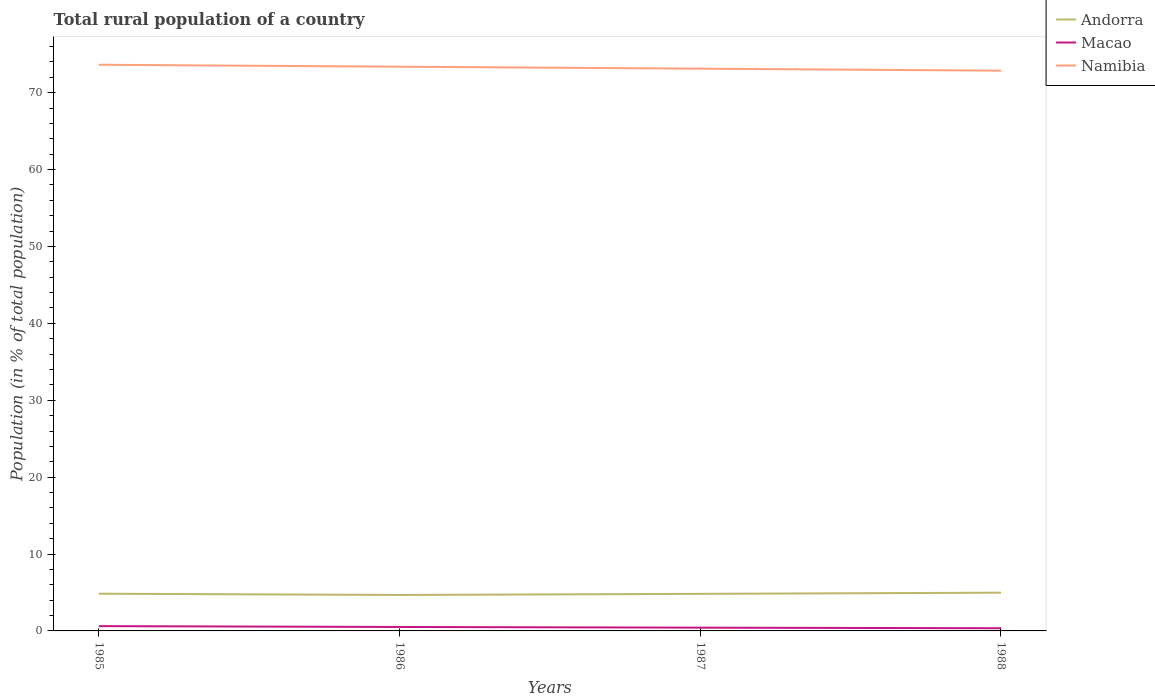Does the line corresponding to Andorra intersect with the line corresponding to Namibia?
Your response must be concise. No. Is the number of lines equal to the number of legend labels?
Your response must be concise. Yes. Across all years, what is the maximum rural population in Andorra?
Make the answer very short. 4.67. What is the total rural population in Macao in the graph?
Keep it short and to the point. 0.27. What is the difference between the highest and the second highest rural population in Macao?
Ensure brevity in your answer.  0.27. What is the difference between the highest and the lowest rural population in Macao?
Ensure brevity in your answer.  2. Is the rural population in Namibia strictly greater than the rural population in Macao over the years?
Offer a terse response. No. Does the graph contain any zero values?
Give a very brief answer. No. How many legend labels are there?
Keep it short and to the point. 3. What is the title of the graph?
Provide a short and direct response. Total rural population of a country. Does "Andorra" appear as one of the legend labels in the graph?
Offer a terse response. Yes. What is the label or title of the Y-axis?
Provide a succinct answer. Population (in % of total population). What is the Population (in % of total population) of Andorra in 1985?
Offer a very short reply. 4.84. What is the Population (in % of total population) of Macao in 1985?
Provide a short and direct response. 0.62. What is the Population (in % of total population) of Namibia in 1985?
Your response must be concise. 73.63. What is the Population (in % of total population) in Andorra in 1986?
Provide a succinct answer. 4.67. What is the Population (in % of total population) in Macao in 1986?
Your answer should be compact. 0.51. What is the Population (in % of total population) in Namibia in 1986?
Your answer should be compact. 73.38. What is the Population (in % of total population) of Andorra in 1987?
Give a very brief answer. 4.82. What is the Population (in % of total population) of Macao in 1987?
Your answer should be very brief. 0.42. What is the Population (in % of total population) of Namibia in 1987?
Your answer should be very brief. 73.12. What is the Population (in % of total population) of Andorra in 1988?
Your answer should be compact. 4.97. What is the Population (in % of total population) of Macao in 1988?
Keep it short and to the point. 0.35. What is the Population (in % of total population) in Namibia in 1988?
Keep it short and to the point. 72.86. Across all years, what is the maximum Population (in % of total population) in Andorra?
Provide a short and direct response. 4.97. Across all years, what is the maximum Population (in % of total population) in Macao?
Provide a succinct answer. 0.62. Across all years, what is the maximum Population (in % of total population) in Namibia?
Offer a very short reply. 73.63. Across all years, what is the minimum Population (in % of total population) in Andorra?
Your answer should be compact. 4.67. Across all years, what is the minimum Population (in % of total population) of Macao?
Make the answer very short. 0.35. Across all years, what is the minimum Population (in % of total population) in Namibia?
Offer a very short reply. 72.86. What is the total Population (in % of total population) of Andorra in the graph?
Your response must be concise. 19.31. What is the total Population (in % of total population) of Macao in the graph?
Provide a succinct answer. 1.91. What is the total Population (in % of total population) in Namibia in the graph?
Offer a very short reply. 293. What is the difference between the Population (in % of total population) in Andorra in 1985 and that in 1986?
Offer a terse response. 0.17. What is the difference between the Population (in % of total population) in Macao in 1985 and that in 1986?
Offer a terse response. 0.11. What is the difference between the Population (in % of total population) in Namibia in 1985 and that in 1986?
Your answer should be very brief. 0.26. What is the difference between the Population (in % of total population) in Andorra in 1985 and that in 1987?
Make the answer very short. 0.02. What is the difference between the Population (in % of total population) of Macao in 1985 and that in 1987?
Provide a short and direct response. 0.2. What is the difference between the Population (in % of total population) in Namibia in 1985 and that in 1987?
Offer a very short reply. 0.51. What is the difference between the Population (in % of total population) of Andorra in 1985 and that in 1988?
Offer a terse response. -0.13. What is the difference between the Population (in % of total population) of Macao in 1985 and that in 1988?
Your answer should be compact. 0.27. What is the difference between the Population (in % of total population) in Namibia in 1985 and that in 1988?
Offer a terse response. 0.77. What is the difference between the Population (in % of total population) in Andorra in 1986 and that in 1987?
Give a very brief answer. -0.15. What is the difference between the Population (in % of total population) in Macao in 1986 and that in 1987?
Provide a short and direct response. 0.09. What is the difference between the Population (in % of total population) of Namibia in 1986 and that in 1987?
Offer a very short reply. 0.26. What is the difference between the Population (in % of total population) of Andorra in 1986 and that in 1988?
Make the answer very short. -0.3. What is the difference between the Population (in % of total population) of Macao in 1986 and that in 1988?
Provide a succinct answer. 0.17. What is the difference between the Population (in % of total population) of Namibia in 1986 and that in 1988?
Make the answer very short. 0.52. What is the difference between the Population (in % of total population) of Andorra in 1987 and that in 1988?
Ensure brevity in your answer.  -0.15. What is the difference between the Population (in % of total population) of Macao in 1987 and that in 1988?
Ensure brevity in your answer.  0.07. What is the difference between the Population (in % of total population) of Namibia in 1987 and that in 1988?
Offer a very short reply. 0.26. What is the difference between the Population (in % of total population) of Andorra in 1985 and the Population (in % of total population) of Macao in 1986?
Keep it short and to the point. 4.33. What is the difference between the Population (in % of total population) of Andorra in 1985 and the Population (in % of total population) of Namibia in 1986?
Offer a very short reply. -68.54. What is the difference between the Population (in % of total population) in Macao in 1985 and the Population (in % of total population) in Namibia in 1986?
Your response must be concise. -72.76. What is the difference between the Population (in % of total population) in Andorra in 1985 and the Population (in % of total population) in Macao in 1987?
Keep it short and to the point. 4.42. What is the difference between the Population (in % of total population) in Andorra in 1985 and the Population (in % of total population) in Namibia in 1987?
Provide a short and direct response. -68.28. What is the difference between the Population (in % of total population) of Macao in 1985 and the Population (in % of total population) of Namibia in 1987?
Provide a succinct answer. -72.5. What is the difference between the Population (in % of total population) of Andorra in 1985 and the Population (in % of total population) of Macao in 1988?
Ensure brevity in your answer.  4.49. What is the difference between the Population (in % of total population) of Andorra in 1985 and the Population (in % of total population) of Namibia in 1988?
Make the answer very short. -68.02. What is the difference between the Population (in % of total population) in Macao in 1985 and the Population (in % of total population) in Namibia in 1988?
Give a very brief answer. -72.24. What is the difference between the Population (in % of total population) of Andorra in 1986 and the Population (in % of total population) of Macao in 1987?
Provide a succinct answer. 4.25. What is the difference between the Population (in % of total population) of Andorra in 1986 and the Population (in % of total population) of Namibia in 1987?
Give a very brief answer. -68.45. What is the difference between the Population (in % of total population) of Macao in 1986 and the Population (in % of total population) of Namibia in 1987?
Offer a terse response. -72.61. What is the difference between the Population (in % of total population) of Andorra in 1986 and the Population (in % of total population) of Macao in 1988?
Offer a terse response. 4.33. What is the difference between the Population (in % of total population) of Andorra in 1986 and the Population (in % of total population) of Namibia in 1988?
Your response must be concise. -68.19. What is the difference between the Population (in % of total population) of Macao in 1986 and the Population (in % of total population) of Namibia in 1988?
Provide a short and direct response. -72.35. What is the difference between the Population (in % of total population) in Andorra in 1987 and the Population (in % of total population) in Macao in 1988?
Ensure brevity in your answer.  4.47. What is the difference between the Population (in % of total population) of Andorra in 1987 and the Population (in % of total population) of Namibia in 1988?
Keep it short and to the point. -68.04. What is the difference between the Population (in % of total population) in Macao in 1987 and the Population (in % of total population) in Namibia in 1988?
Your response must be concise. -72.44. What is the average Population (in % of total population) of Andorra per year?
Your answer should be very brief. 4.83. What is the average Population (in % of total population) of Macao per year?
Ensure brevity in your answer.  0.48. What is the average Population (in % of total population) of Namibia per year?
Your answer should be very brief. 73.25. In the year 1985, what is the difference between the Population (in % of total population) in Andorra and Population (in % of total population) in Macao?
Give a very brief answer. 4.22. In the year 1985, what is the difference between the Population (in % of total population) of Andorra and Population (in % of total population) of Namibia?
Give a very brief answer. -68.79. In the year 1985, what is the difference between the Population (in % of total population) in Macao and Population (in % of total population) in Namibia?
Make the answer very short. -73.01. In the year 1986, what is the difference between the Population (in % of total population) of Andorra and Population (in % of total population) of Macao?
Your response must be concise. 4.16. In the year 1986, what is the difference between the Population (in % of total population) in Andorra and Population (in % of total population) in Namibia?
Your response must be concise. -68.7. In the year 1986, what is the difference between the Population (in % of total population) of Macao and Population (in % of total population) of Namibia?
Offer a terse response. -72.86. In the year 1987, what is the difference between the Population (in % of total population) in Andorra and Population (in % of total population) in Macao?
Provide a short and direct response. 4.4. In the year 1987, what is the difference between the Population (in % of total population) of Andorra and Population (in % of total population) of Namibia?
Ensure brevity in your answer.  -68.3. In the year 1987, what is the difference between the Population (in % of total population) in Macao and Population (in % of total population) in Namibia?
Provide a short and direct response. -72.7. In the year 1988, what is the difference between the Population (in % of total population) in Andorra and Population (in % of total population) in Macao?
Give a very brief answer. 4.62. In the year 1988, what is the difference between the Population (in % of total population) in Andorra and Population (in % of total population) in Namibia?
Make the answer very short. -67.89. In the year 1988, what is the difference between the Population (in % of total population) in Macao and Population (in % of total population) in Namibia?
Keep it short and to the point. -72.52. What is the ratio of the Population (in % of total population) in Andorra in 1985 to that in 1986?
Keep it short and to the point. 1.04. What is the ratio of the Population (in % of total population) in Macao in 1985 to that in 1986?
Your answer should be compact. 1.21. What is the ratio of the Population (in % of total population) in Namibia in 1985 to that in 1986?
Make the answer very short. 1. What is the ratio of the Population (in % of total population) of Macao in 1985 to that in 1987?
Give a very brief answer. 1.47. What is the ratio of the Population (in % of total population) of Andorra in 1985 to that in 1988?
Make the answer very short. 0.97. What is the ratio of the Population (in % of total population) of Macao in 1985 to that in 1988?
Your answer should be compact. 1.79. What is the ratio of the Population (in % of total population) in Namibia in 1985 to that in 1988?
Make the answer very short. 1.01. What is the ratio of the Population (in % of total population) of Andorra in 1986 to that in 1987?
Make the answer very short. 0.97. What is the ratio of the Population (in % of total population) in Macao in 1986 to that in 1987?
Give a very brief answer. 1.21. What is the ratio of the Population (in % of total population) in Andorra in 1986 to that in 1988?
Give a very brief answer. 0.94. What is the ratio of the Population (in % of total population) in Macao in 1986 to that in 1988?
Your answer should be very brief. 1.47. What is the ratio of the Population (in % of total population) of Namibia in 1986 to that in 1988?
Ensure brevity in your answer.  1.01. What is the ratio of the Population (in % of total population) of Andorra in 1987 to that in 1988?
Give a very brief answer. 0.97. What is the ratio of the Population (in % of total population) in Macao in 1987 to that in 1988?
Offer a very short reply. 1.21. What is the ratio of the Population (in % of total population) of Namibia in 1987 to that in 1988?
Your response must be concise. 1. What is the difference between the highest and the second highest Population (in % of total population) of Andorra?
Ensure brevity in your answer.  0.13. What is the difference between the highest and the second highest Population (in % of total population) in Macao?
Offer a terse response. 0.11. What is the difference between the highest and the second highest Population (in % of total population) in Namibia?
Provide a short and direct response. 0.26. What is the difference between the highest and the lowest Population (in % of total population) in Andorra?
Your answer should be very brief. 0.3. What is the difference between the highest and the lowest Population (in % of total population) of Macao?
Your answer should be compact. 0.27. What is the difference between the highest and the lowest Population (in % of total population) of Namibia?
Your answer should be very brief. 0.77. 